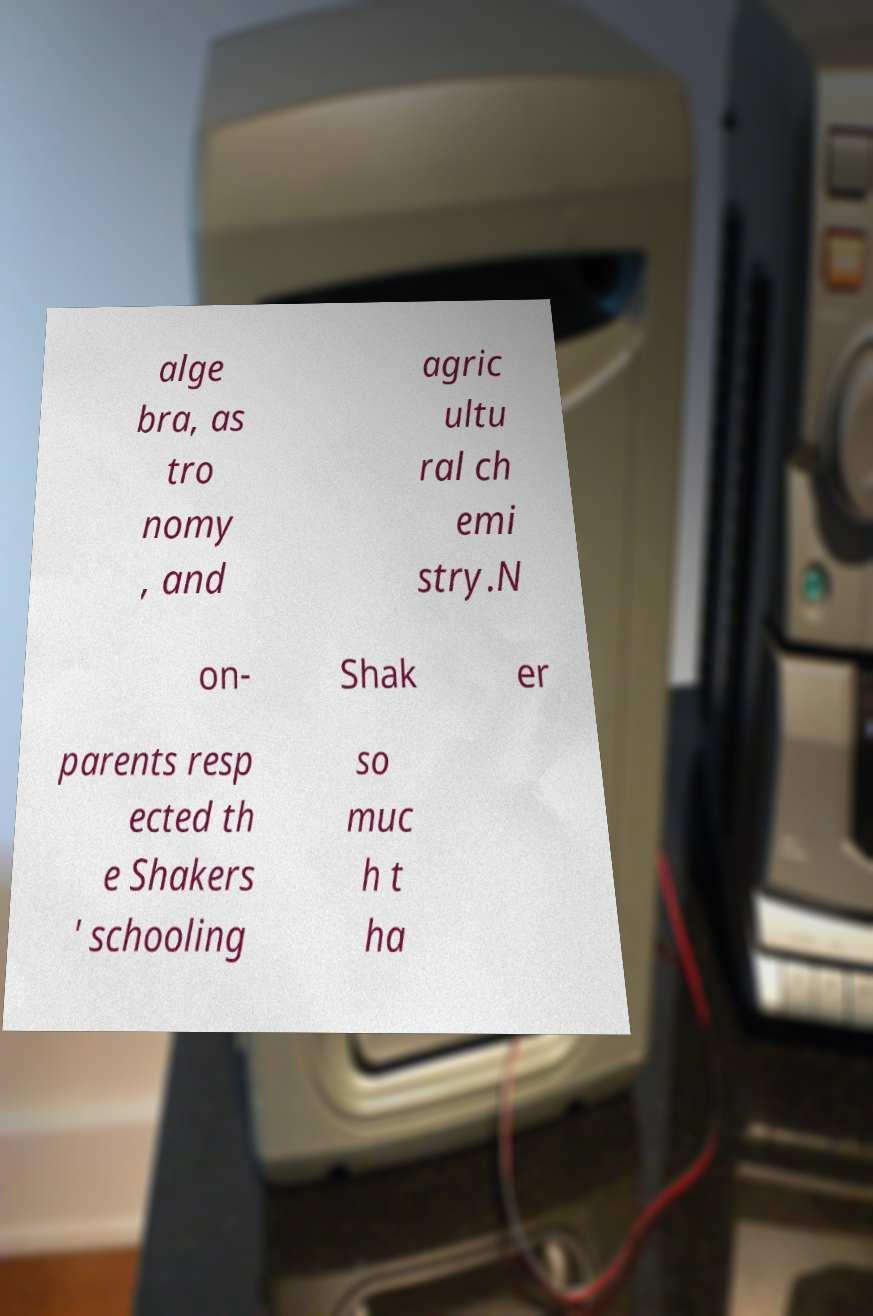Could you assist in decoding the text presented in this image and type it out clearly? alge bra, as tro nomy , and agric ultu ral ch emi stry.N on- Shak er parents resp ected th e Shakers ' schooling so muc h t ha 